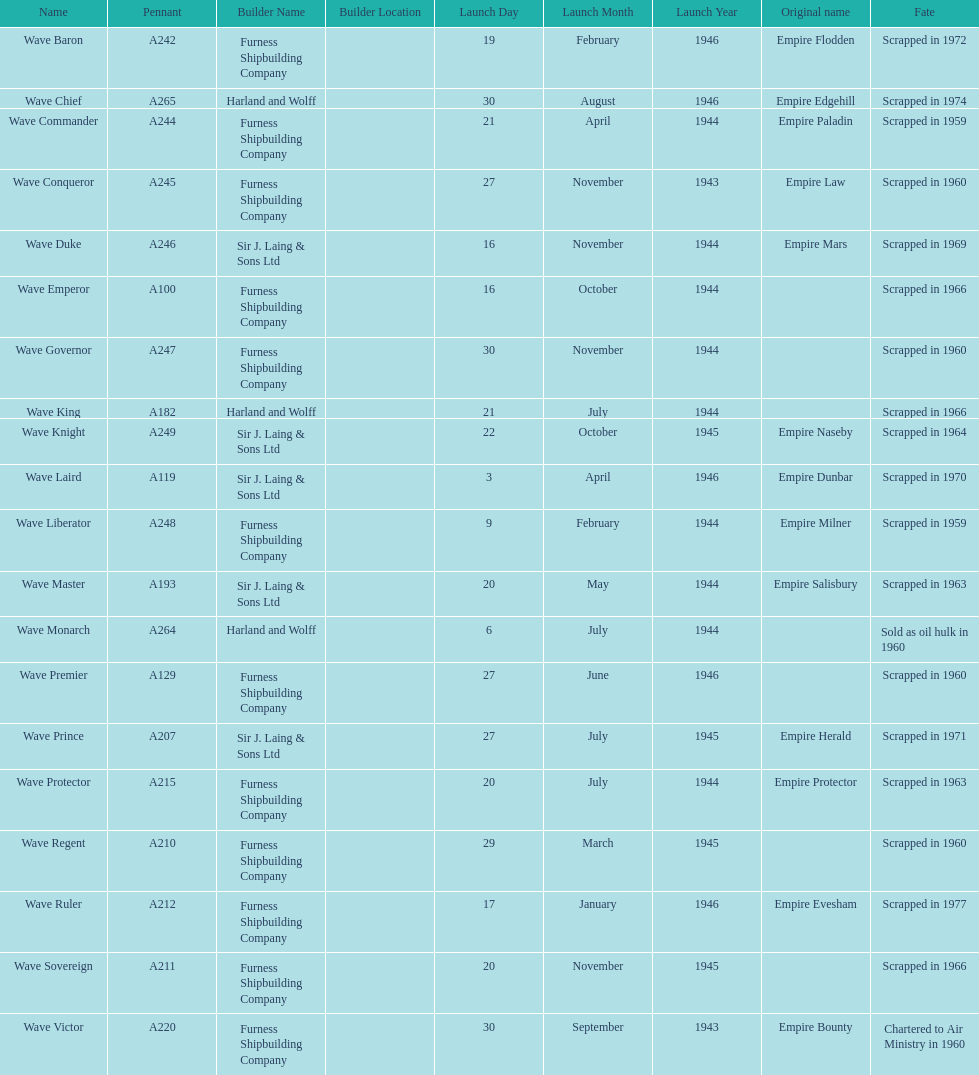How many ships were launched in the year 1944? 9. 